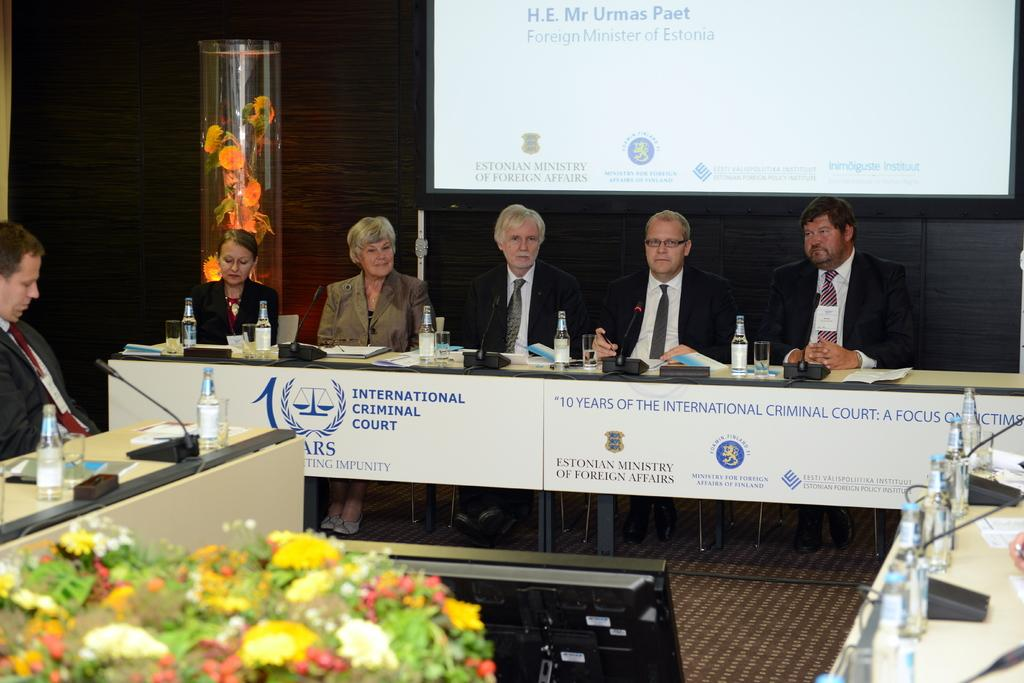What are the people in the image doing? The people in the image are sitting in chairs. Where are the chairs located in relation to the table? The chairs are in front of a table. What can be seen on the table in the image? There is a bottle and a glass on the table in the image. What device is present in the image for communication? There is a telephone in the image. What type of headwear is the person wearing in the image? There is no person wearing headwear in the image. Is there any milk visible in the image? There is no milk present in the image. Is there any sleet visible in the image? There is no sleet present in the image. 